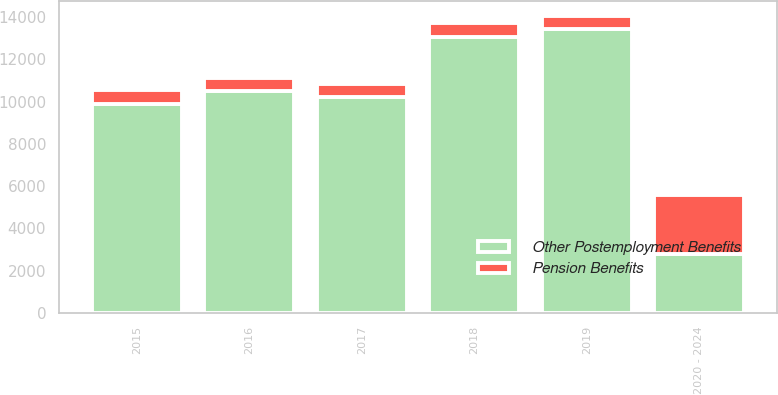Convert chart. <chart><loc_0><loc_0><loc_500><loc_500><stacked_bar_chart><ecel><fcel>2015<fcel>2016<fcel>2017<fcel>2018<fcel>2019<fcel>2020 - 2024<nl><fcel>Other Postemployment Benefits<fcel>9885<fcel>10477<fcel>10211<fcel>13069<fcel>13444<fcel>2800<nl><fcel>Pension Benefits<fcel>641<fcel>624<fcel>616<fcel>627<fcel>597<fcel>2800<nl></chart> 